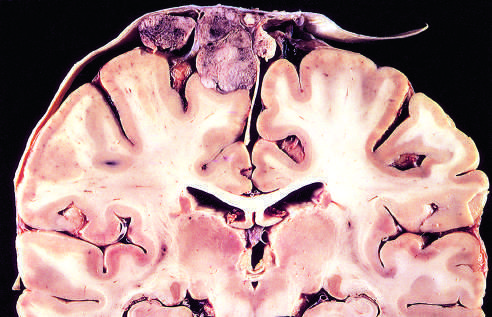what is parasagittal multilobular meningioma attached to?
Answer the question using a single word or phrase. The dura with compression of underlying brain 